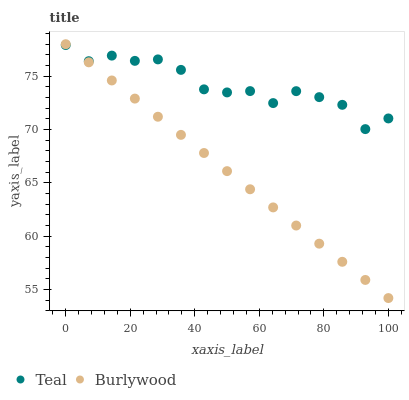Does Burlywood have the minimum area under the curve?
Answer yes or no. Yes. Does Teal have the maximum area under the curve?
Answer yes or no. Yes. Does Teal have the minimum area under the curve?
Answer yes or no. No. Is Burlywood the smoothest?
Answer yes or no. Yes. Is Teal the roughest?
Answer yes or no. Yes. Is Teal the smoothest?
Answer yes or no. No. Does Burlywood have the lowest value?
Answer yes or no. Yes. Does Teal have the lowest value?
Answer yes or no. No. Does Burlywood have the highest value?
Answer yes or no. Yes. Does Teal have the highest value?
Answer yes or no. No. Does Teal intersect Burlywood?
Answer yes or no. Yes. Is Teal less than Burlywood?
Answer yes or no. No. Is Teal greater than Burlywood?
Answer yes or no. No. 